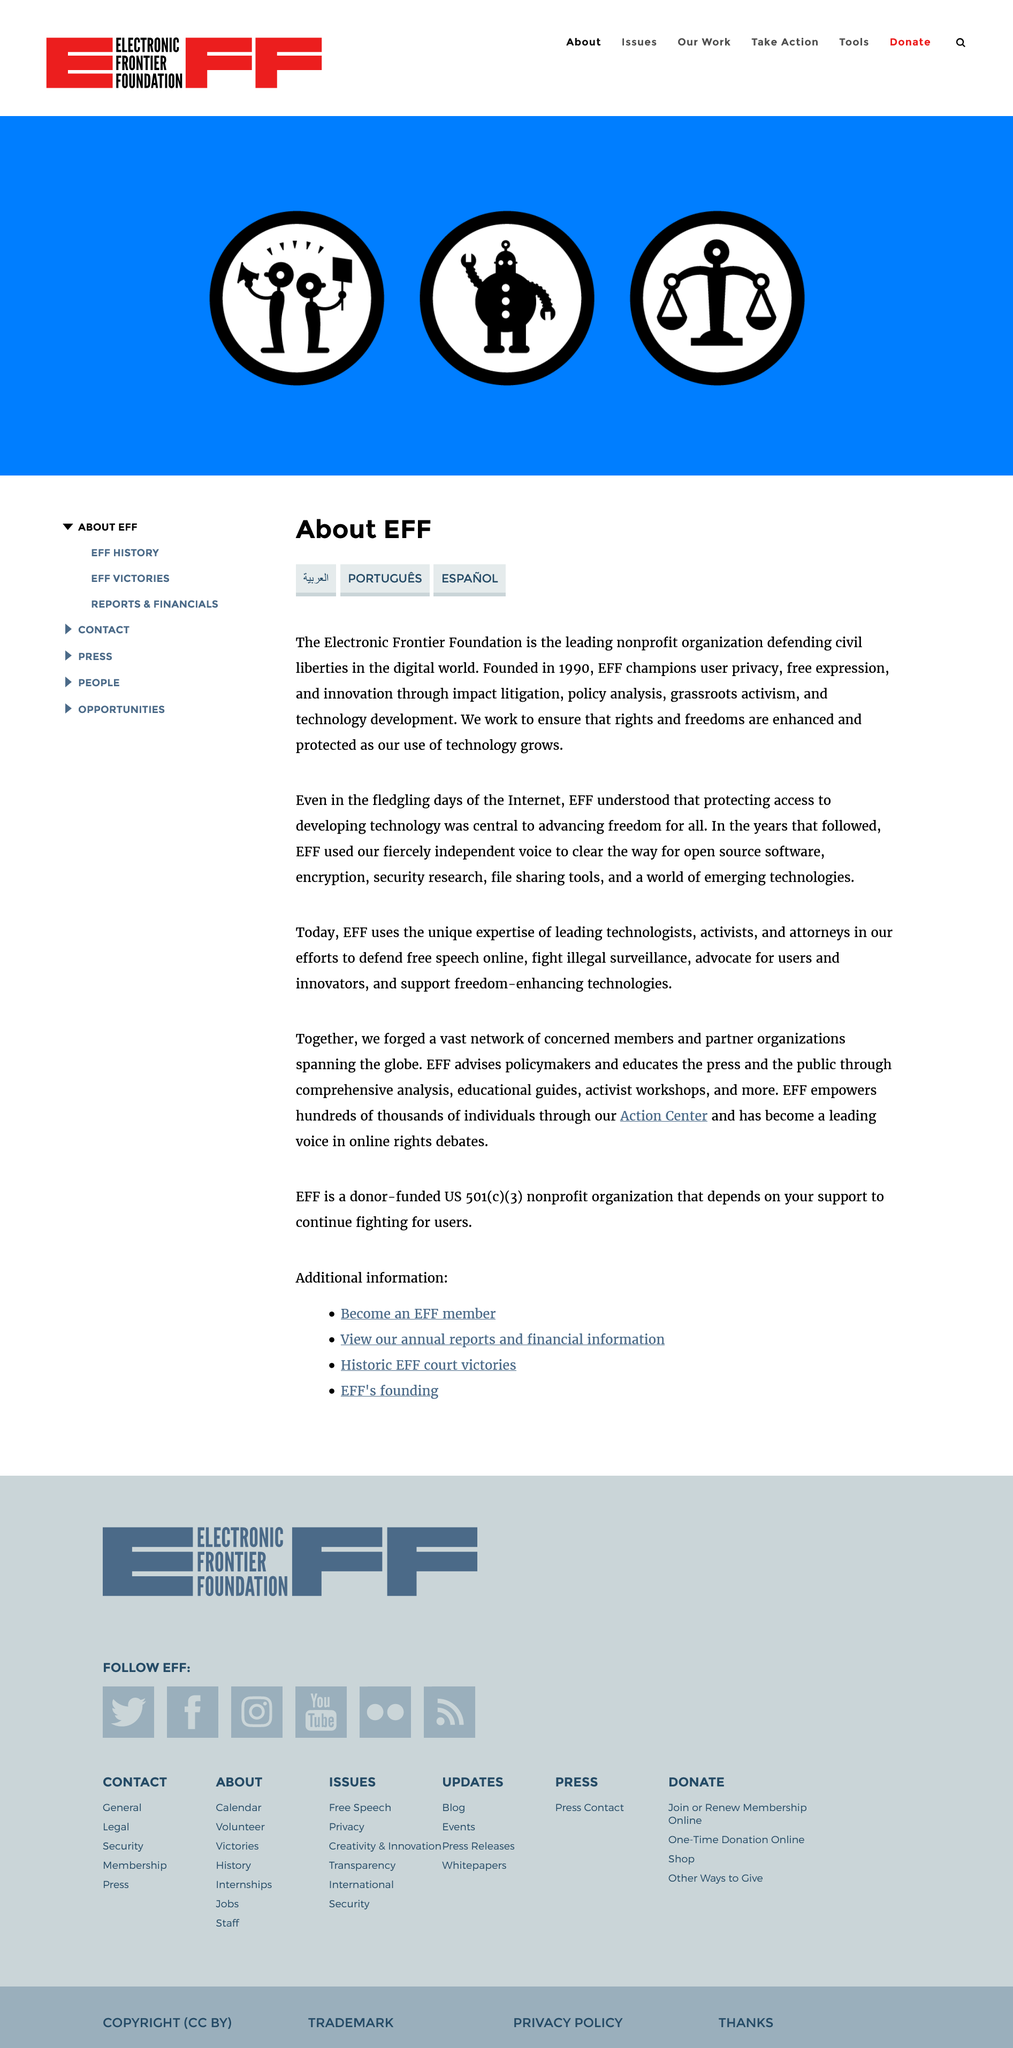Mention a couple of crucial points in this snapshot. The title of the page is "About EFF". This page is available in four languages, including English. The abbreviation "EFF" stands for "Electronic Frontier Foundation," which is a non-profit organization that advocates for digital rights and freedoms. 